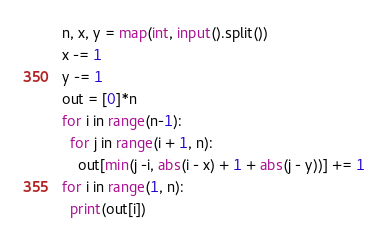<code> <loc_0><loc_0><loc_500><loc_500><_Python_>n, x, y = map(int, input().split())
x -= 1
y -= 1
out = [0]*n
for i in range(n-1):
  for j in range(i + 1, n):
    out[min(j -i, abs(i - x) + 1 + abs(j - y))] += 1
for i in range(1, n):
  print(out[i])</code> 